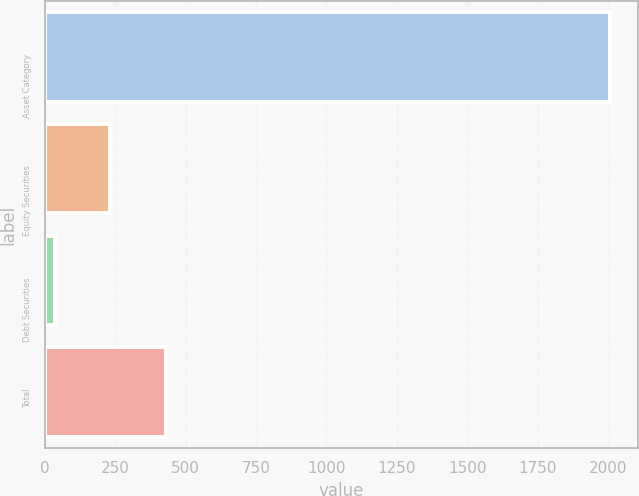<chart> <loc_0><loc_0><loc_500><loc_500><bar_chart><fcel>Asset Category<fcel>Equity Securities<fcel>Debt Securities<fcel>Total<nl><fcel>2007<fcel>232.2<fcel>35<fcel>429.4<nl></chart> 